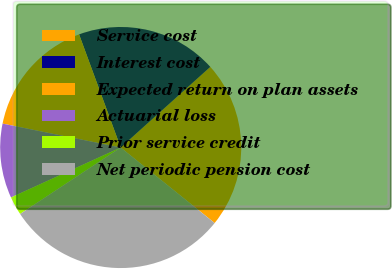Convert chart to OTSL. <chart><loc_0><loc_0><loc_500><loc_500><pie_chart><fcel>Service cost<fcel>Interest cost<fcel>Expected return on plan assets<fcel>Actuarial loss<fcel>Prior service credit<fcel>Net periodic pension cost<nl><fcel>22.44%<fcel>18.95%<fcel>16.21%<fcel>9.98%<fcel>2.49%<fcel>29.93%<nl></chart> 